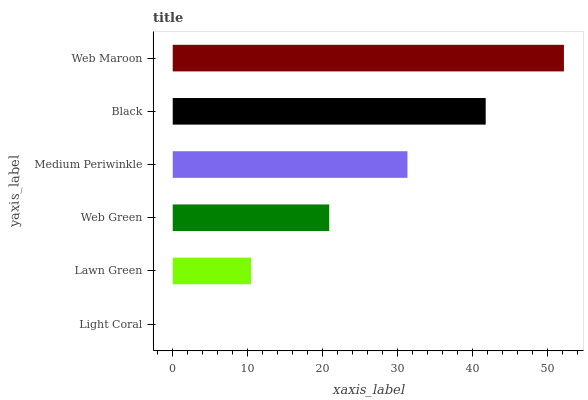Is Light Coral the minimum?
Answer yes or no. Yes. Is Web Maroon the maximum?
Answer yes or no. Yes. Is Lawn Green the minimum?
Answer yes or no. No. Is Lawn Green the maximum?
Answer yes or no. No. Is Lawn Green greater than Light Coral?
Answer yes or no. Yes. Is Light Coral less than Lawn Green?
Answer yes or no. Yes. Is Light Coral greater than Lawn Green?
Answer yes or no. No. Is Lawn Green less than Light Coral?
Answer yes or no. No. Is Medium Periwinkle the high median?
Answer yes or no. Yes. Is Web Green the low median?
Answer yes or no. Yes. Is Black the high median?
Answer yes or no. No. Is Web Maroon the low median?
Answer yes or no. No. 